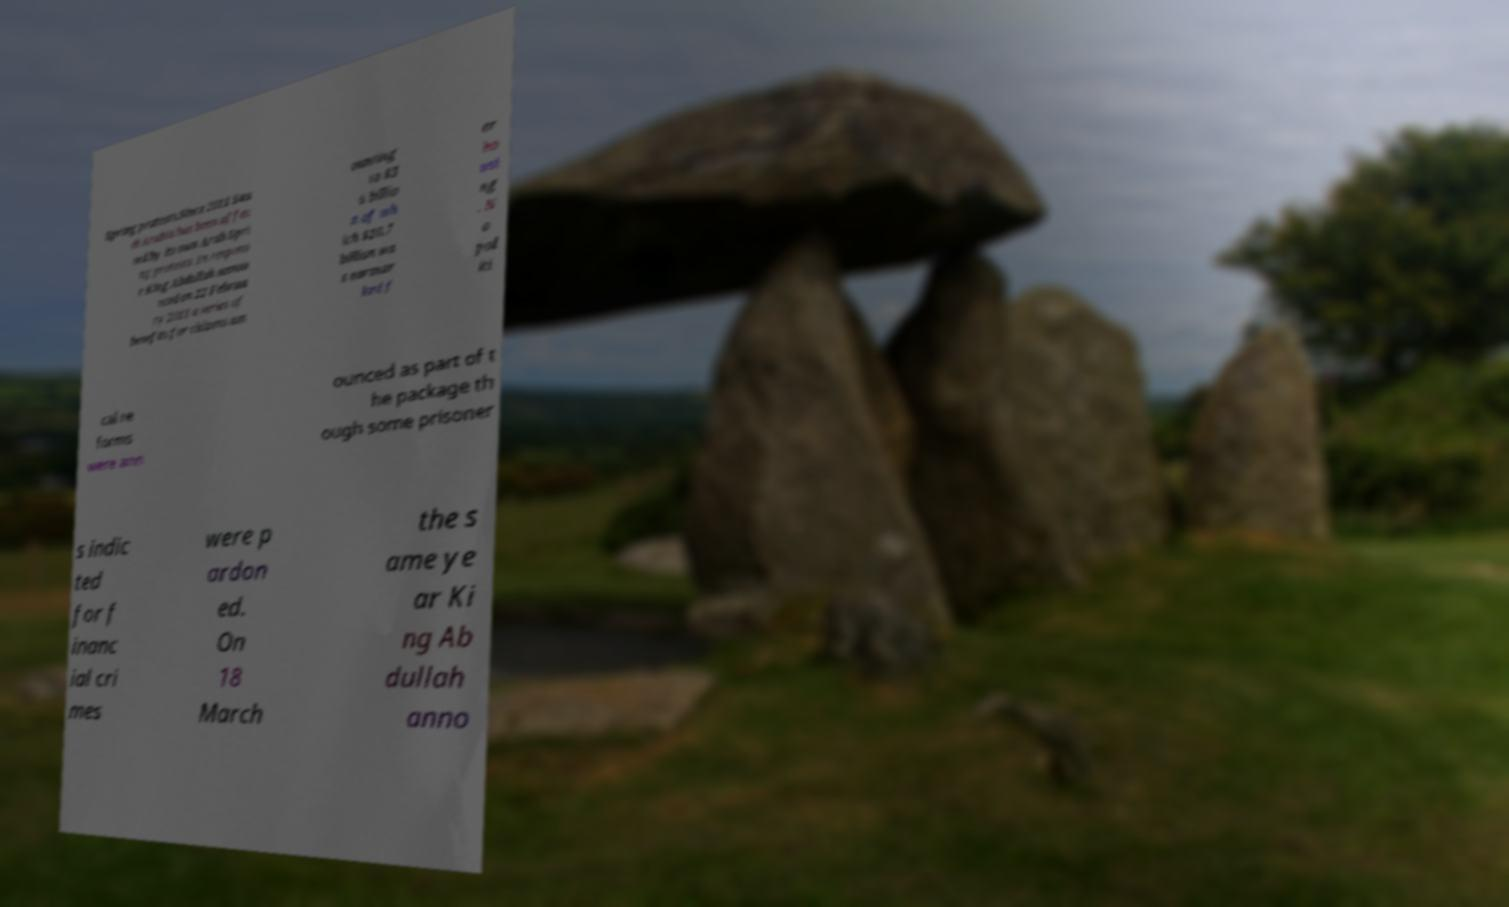Can you read and provide the text displayed in the image?This photo seems to have some interesting text. Can you extract and type it out for me? Spring protests.Since 2011 Sau di Arabia has been affec ted by its own Arab Spri ng protests. In respons e King Abdullah annou nced on 22 Februa ry 2011 a series of benefits for citizens am ounting to $3 6 billio n of wh ich $10.7 billion wa s earmar ked f or ho usi ng . N o pol iti cal re forms were ann ounced as part of t he package th ough some prisoner s indic ted for f inanc ial cri mes were p ardon ed. On 18 March the s ame ye ar Ki ng Ab dullah anno 